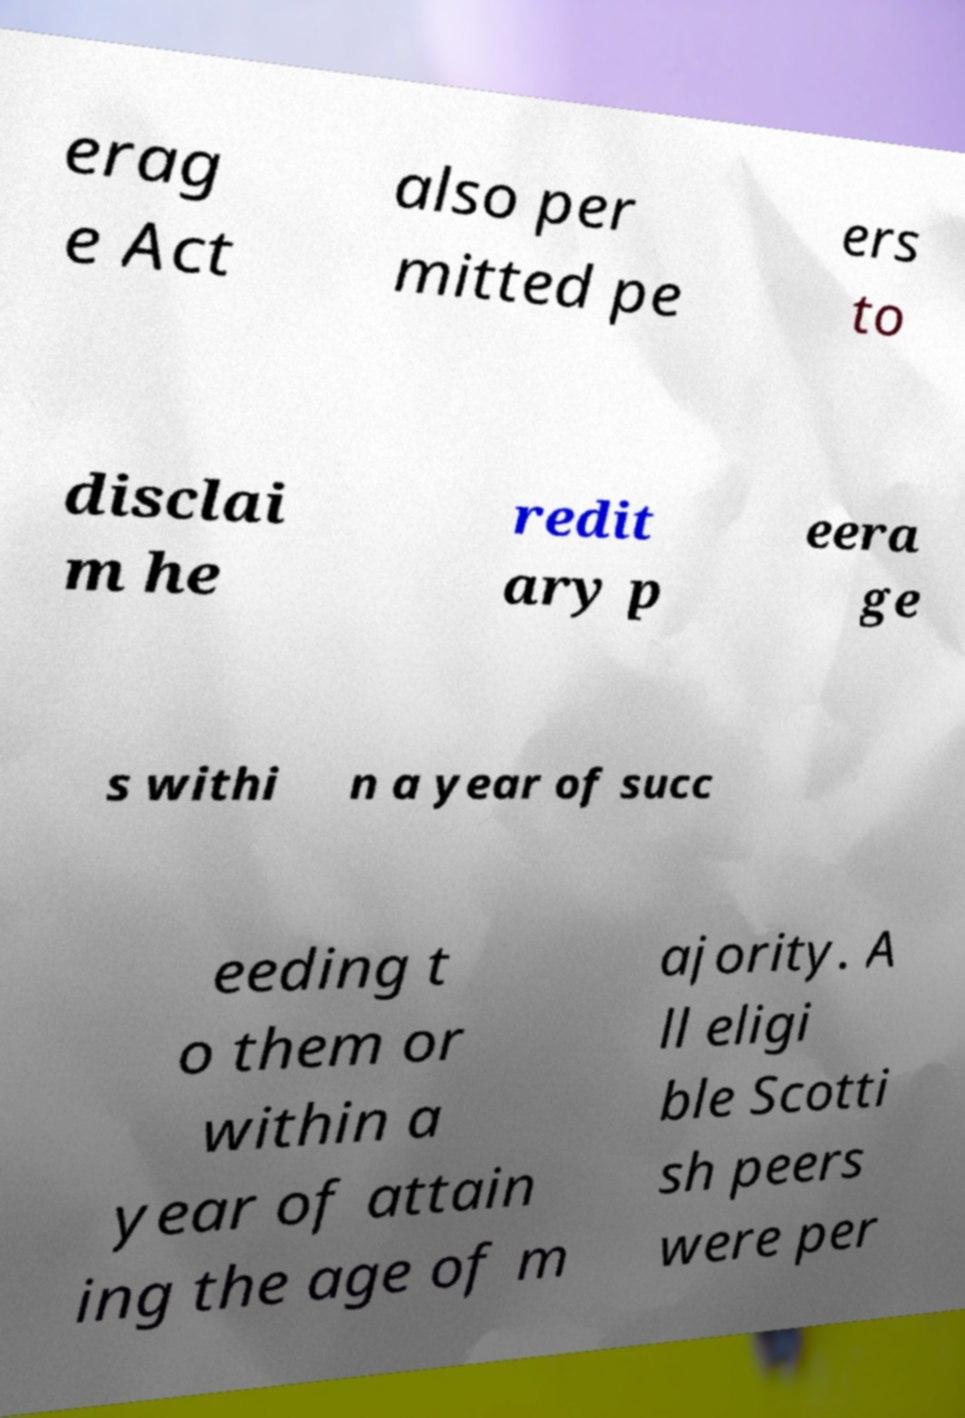Please identify and transcribe the text found in this image. erag e Act also per mitted pe ers to disclai m he redit ary p eera ge s withi n a year of succ eeding t o them or within a year of attain ing the age of m ajority. A ll eligi ble Scotti sh peers were per 